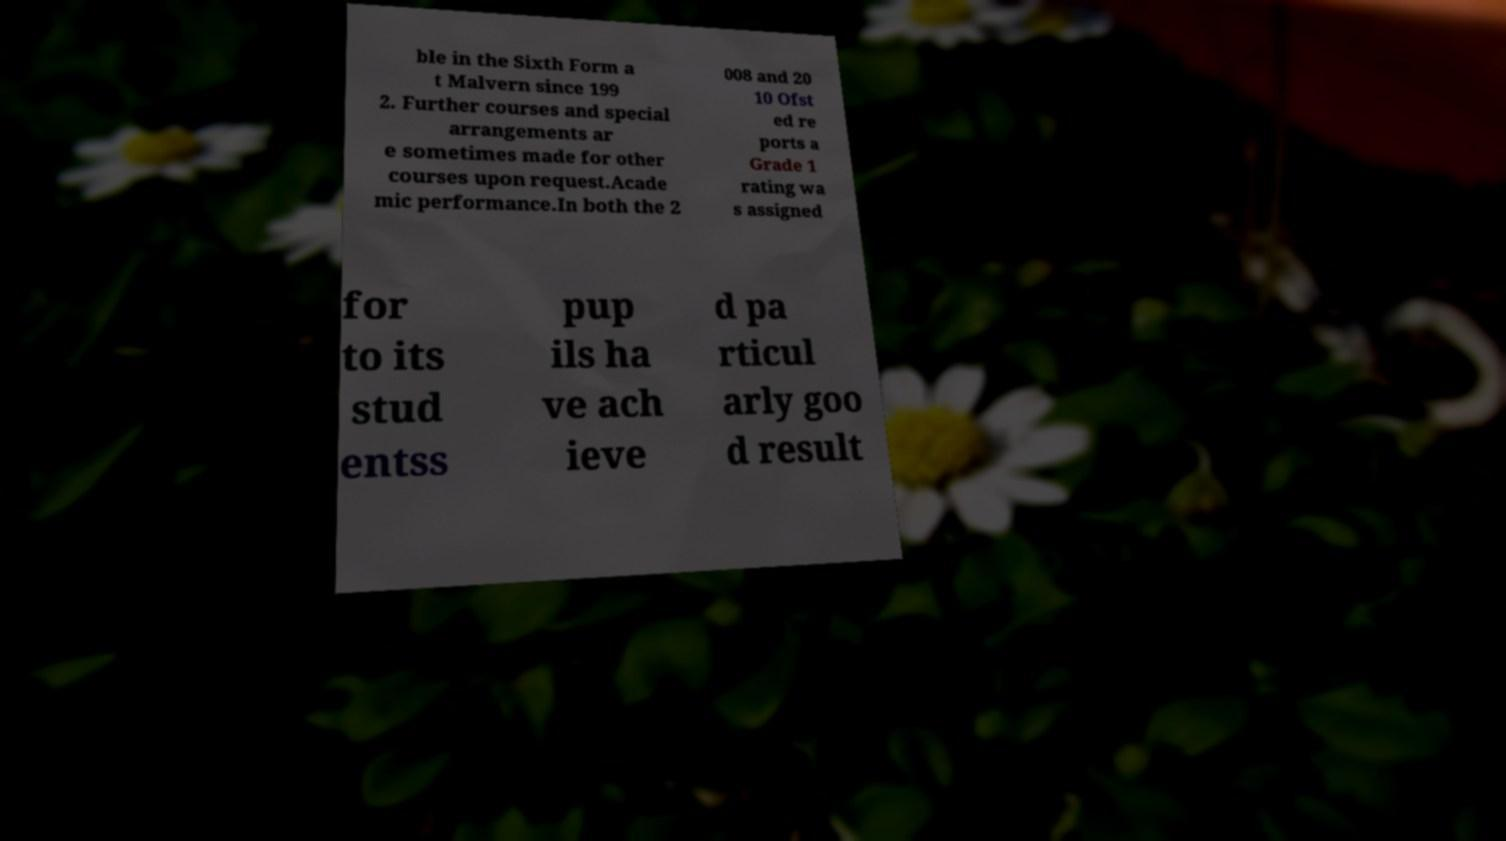Can you accurately transcribe the text from the provided image for me? ble in the Sixth Form a t Malvern since 199 2. Further courses and special arrangements ar e sometimes made for other courses upon request.Acade mic performance.In both the 2 008 and 20 10 Ofst ed re ports a Grade 1 rating wa s assigned for to its stud entss pup ils ha ve ach ieve d pa rticul arly goo d result 